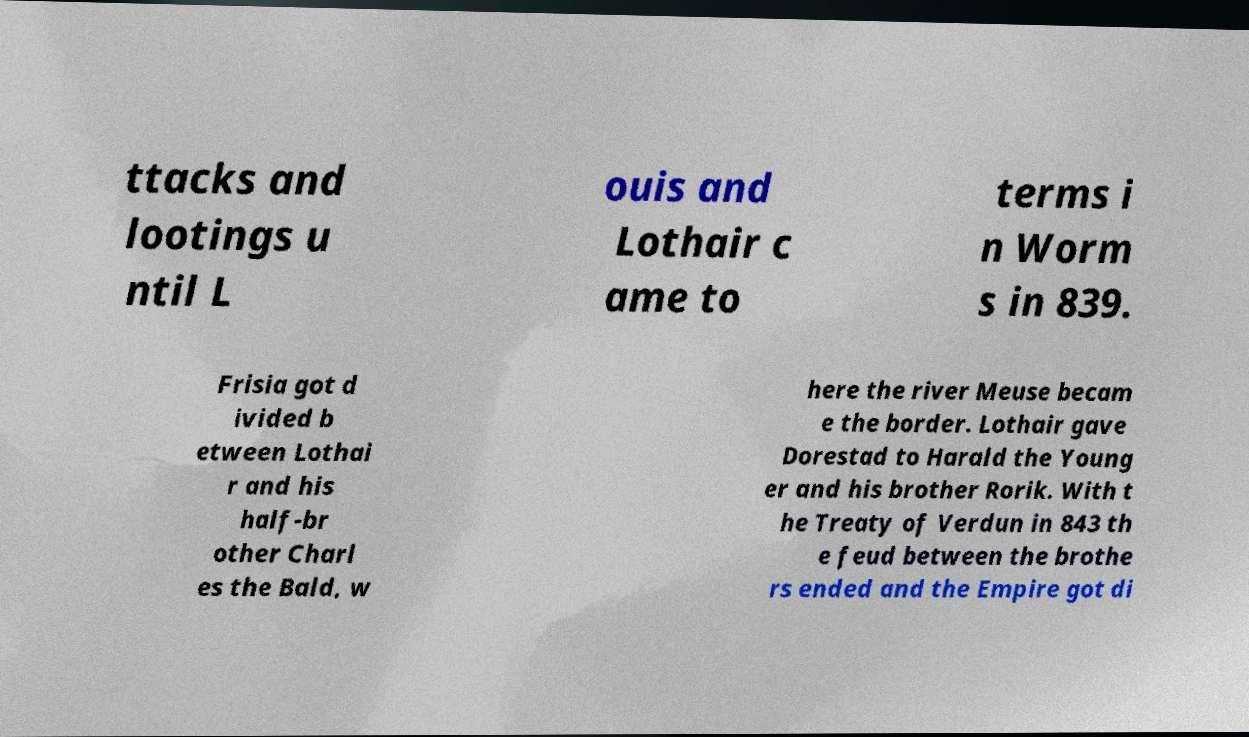There's text embedded in this image that I need extracted. Can you transcribe it verbatim? ttacks and lootings u ntil L ouis and Lothair c ame to terms i n Worm s in 839. Frisia got d ivided b etween Lothai r and his half-br other Charl es the Bald, w here the river Meuse becam e the border. Lothair gave Dorestad to Harald the Young er and his brother Rorik. With t he Treaty of Verdun in 843 th e feud between the brothe rs ended and the Empire got di 